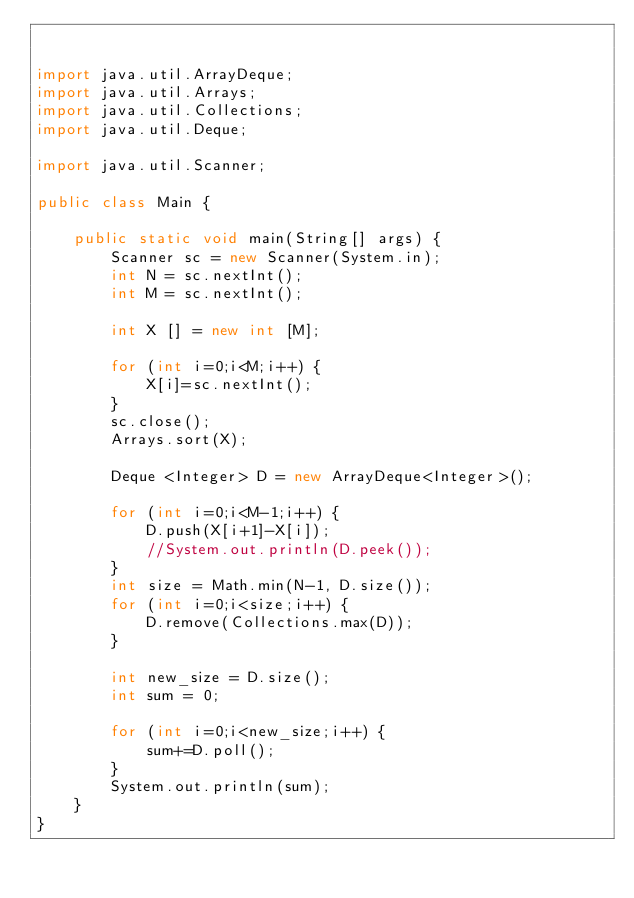<code> <loc_0><loc_0><loc_500><loc_500><_Java_>

import java.util.ArrayDeque;
import java.util.Arrays;
import java.util.Collections;
import java.util.Deque;

import java.util.Scanner;

public class Main {

	public static void main(String[] args) {
		Scanner sc = new Scanner(System.in);
	    int N = sc.nextInt();
	    int M = sc.nextInt();
	    
	    int X [] = new int [M];

	    for (int i=0;i<M;i++) {
	    	X[i]=sc.nextInt();
	    }
	    sc.close(); 
	    Arrays.sort(X);
	    
	    Deque <Integer> D = new ArrayDeque<Integer>(); 

	    for (int i=0;i<M-1;i++) {
	    	D.push(X[i+1]-X[i]);
	    	//System.out.println(D.peek());
	    }
	    int size = Math.min(N-1, D.size());
	    for (int i=0;i<size;i++) {
	    	D.remove(Collections.max(D));
	    }
	    
	    int new_size = D.size();
	    int sum = 0;
	    
	    for (int i=0;i<new_size;i++) {
	    	sum+=D.poll();
	    }
	    System.out.println(sum);
	}
}


</code> 